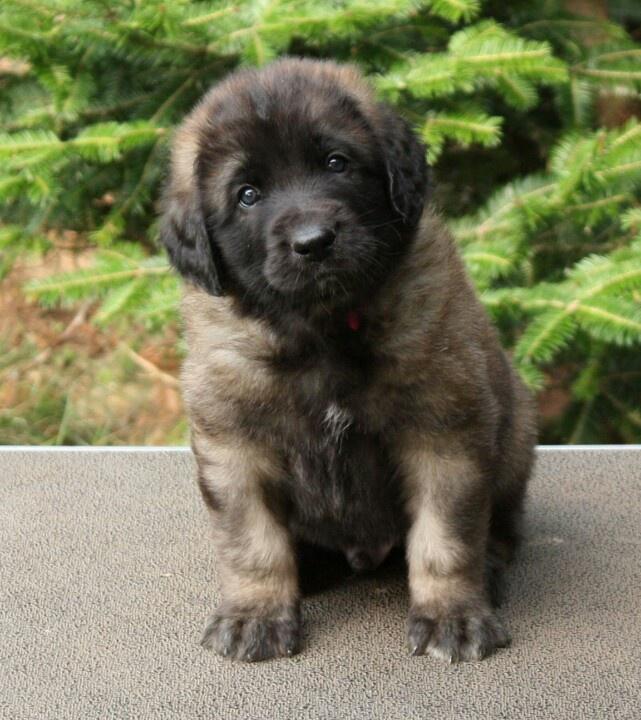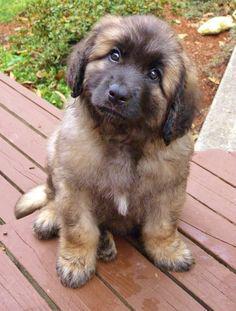The first image is the image on the left, the second image is the image on the right. Evaluate the accuracy of this statement regarding the images: "One image features two dogs, and adult and a puppy, in an outdoor setting.". Is it true? Answer yes or no. No. The first image is the image on the left, the second image is the image on the right. Assess this claim about the two images: "An image shows one big dog and one small dog outdoors.". Correct or not? Answer yes or no. No. 